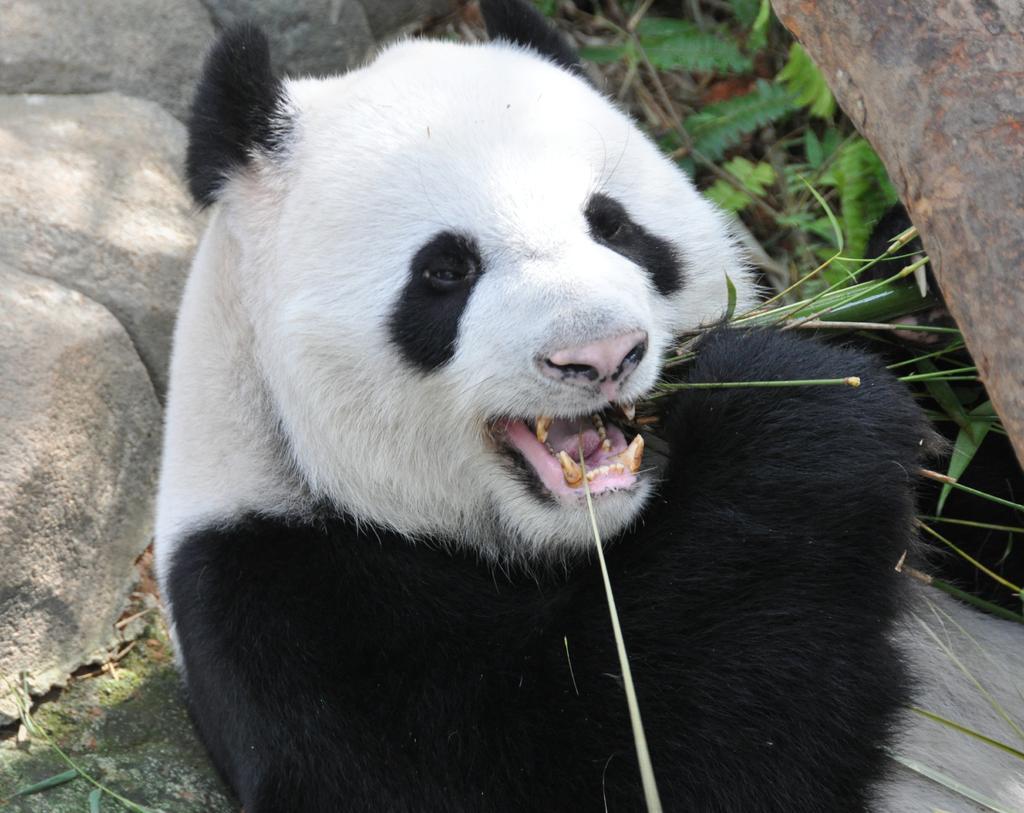In one or two sentences, can you explain what this image depicts? In this image we can see a panda eating plants. In the background, we can see the rocks and plants on the ground. 